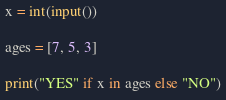Convert code to text. <code><loc_0><loc_0><loc_500><loc_500><_Python_>x = int(input())

ages = [7, 5, 3]

print("YES" if x in ages else "NO")</code> 